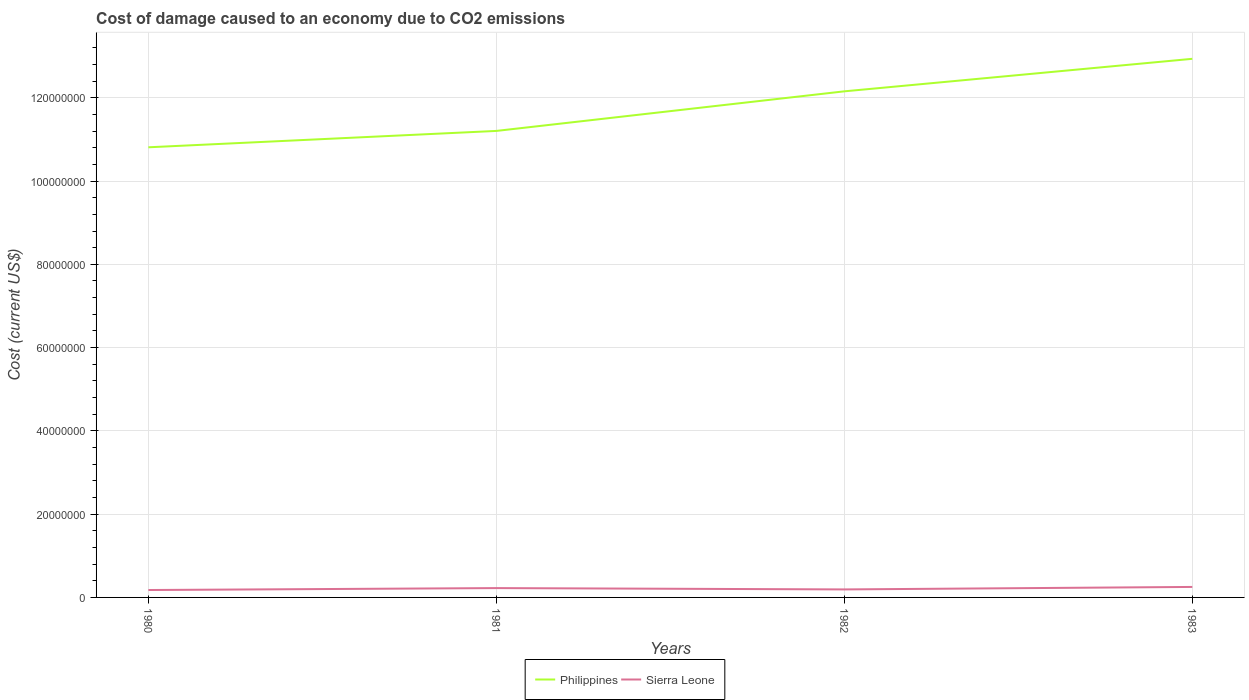Does the line corresponding to Sierra Leone intersect with the line corresponding to Philippines?
Provide a short and direct response. No. Across all years, what is the maximum cost of damage caused due to CO2 emissisons in Sierra Leone?
Give a very brief answer. 1.78e+06. What is the total cost of damage caused due to CO2 emissisons in Sierra Leone in the graph?
Your answer should be compact. -2.78e+05. What is the difference between the highest and the second highest cost of damage caused due to CO2 emissisons in Sierra Leone?
Ensure brevity in your answer.  7.40e+05. What is the difference between the highest and the lowest cost of damage caused due to CO2 emissisons in Philippines?
Your answer should be very brief. 2. Is the cost of damage caused due to CO2 emissisons in Philippines strictly greater than the cost of damage caused due to CO2 emissisons in Sierra Leone over the years?
Make the answer very short. No. How many lines are there?
Provide a succinct answer. 2. How many years are there in the graph?
Your answer should be compact. 4. Where does the legend appear in the graph?
Your response must be concise. Bottom center. What is the title of the graph?
Give a very brief answer. Cost of damage caused to an economy due to CO2 emissions. What is the label or title of the Y-axis?
Your answer should be compact. Cost (current US$). What is the Cost (current US$) of Philippines in 1980?
Your answer should be compact. 1.08e+08. What is the Cost (current US$) of Sierra Leone in 1980?
Give a very brief answer. 1.78e+06. What is the Cost (current US$) of Philippines in 1981?
Your response must be concise. 1.12e+08. What is the Cost (current US$) in Sierra Leone in 1981?
Offer a very short reply. 2.24e+06. What is the Cost (current US$) of Philippines in 1982?
Your answer should be compact. 1.22e+08. What is the Cost (current US$) in Sierra Leone in 1982?
Give a very brief answer. 1.92e+06. What is the Cost (current US$) of Philippines in 1983?
Keep it short and to the point. 1.29e+08. What is the Cost (current US$) in Sierra Leone in 1983?
Provide a succinct answer. 2.52e+06. Across all years, what is the maximum Cost (current US$) of Philippines?
Provide a succinct answer. 1.29e+08. Across all years, what is the maximum Cost (current US$) of Sierra Leone?
Provide a short and direct response. 2.52e+06. Across all years, what is the minimum Cost (current US$) of Philippines?
Keep it short and to the point. 1.08e+08. Across all years, what is the minimum Cost (current US$) of Sierra Leone?
Keep it short and to the point. 1.78e+06. What is the total Cost (current US$) of Philippines in the graph?
Offer a very short reply. 4.71e+08. What is the total Cost (current US$) in Sierra Leone in the graph?
Offer a very short reply. 8.46e+06. What is the difference between the Cost (current US$) in Philippines in 1980 and that in 1981?
Your answer should be compact. -3.93e+06. What is the difference between the Cost (current US$) in Sierra Leone in 1980 and that in 1981?
Make the answer very short. -4.62e+05. What is the difference between the Cost (current US$) of Philippines in 1980 and that in 1982?
Provide a succinct answer. -1.34e+07. What is the difference between the Cost (current US$) in Sierra Leone in 1980 and that in 1982?
Give a very brief answer. -1.44e+05. What is the difference between the Cost (current US$) of Philippines in 1980 and that in 1983?
Keep it short and to the point. -2.13e+07. What is the difference between the Cost (current US$) of Sierra Leone in 1980 and that in 1983?
Provide a succinct answer. -7.40e+05. What is the difference between the Cost (current US$) in Philippines in 1981 and that in 1982?
Offer a terse response. -9.51e+06. What is the difference between the Cost (current US$) of Sierra Leone in 1981 and that in 1982?
Provide a short and direct response. 3.17e+05. What is the difference between the Cost (current US$) of Philippines in 1981 and that in 1983?
Ensure brevity in your answer.  -1.73e+07. What is the difference between the Cost (current US$) of Sierra Leone in 1981 and that in 1983?
Your answer should be compact. -2.78e+05. What is the difference between the Cost (current US$) in Philippines in 1982 and that in 1983?
Make the answer very short. -7.81e+06. What is the difference between the Cost (current US$) of Sierra Leone in 1982 and that in 1983?
Provide a succinct answer. -5.95e+05. What is the difference between the Cost (current US$) in Philippines in 1980 and the Cost (current US$) in Sierra Leone in 1981?
Your response must be concise. 1.06e+08. What is the difference between the Cost (current US$) of Philippines in 1980 and the Cost (current US$) of Sierra Leone in 1982?
Offer a very short reply. 1.06e+08. What is the difference between the Cost (current US$) in Philippines in 1980 and the Cost (current US$) in Sierra Leone in 1983?
Give a very brief answer. 1.06e+08. What is the difference between the Cost (current US$) in Philippines in 1981 and the Cost (current US$) in Sierra Leone in 1982?
Keep it short and to the point. 1.10e+08. What is the difference between the Cost (current US$) in Philippines in 1981 and the Cost (current US$) in Sierra Leone in 1983?
Offer a very short reply. 1.10e+08. What is the difference between the Cost (current US$) of Philippines in 1982 and the Cost (current US$) of Sierra Leone in 1983?
Your answer should be very brief. 1.19e+08. What is the average Cost (current US$) in Philippines per year?
Your response must be concise. 1.18e+08. What is the average Cost (current US$) of Sierra Leone per year?
Your answer should be very brief. 2.12e+06. In the year 1980, what is the difference between the Cost (current US$) in Philippines and Cost (current US$) in Sierra Leone?
Make the answer very short. 1.06e+08. In the year 1981, what is the difference between the Cost (current US$) of Philippines and Cost (current US$) of Sierra Leone?
Your answer should be compact. 1.10e+08. In the year 1982, what is the difference between the Cost (current US$) in Philippines and Cost (current US$) in Sierra Leone?
Keep it short and to the point. 1.20e+08. In the year 1983, what is the difference between the Cost (current US$) of Philippines and Cost (current US$) of Sierra Leone?
Offer a terse response. 1.27e+08. What is the ratio of the Cost (current US$) in Philippines in 1980 to that in 1981?
Ensure brevity in your answer.  0.96. What is the ratio of the Cost (current US$) in Sierra Leone in 1980 to that in 1981?
Provide a short and direct response. 0.79. What is the ratio of the Cost (current US$) of Philippines in 1980 to that in 1982?
Ensure brevity in your answer.  0.89. What is the ratio of the Cost (current US$) in Sierra Leone in 1980 to that in 1982?
Offer a very short reply. 0.92. What is the ratio of the Cost (current US$) of Philippines in 1980 to that in 1983?
Give a very brief answer. 0.84. What is the ratio of the Cost (current US$) in Sierra Leone in 1980 to that in 1983?
Your response must be concise. 0.71. What is the ratio of the Cost (current US$) of Philippines in 1981 to that in 1982?
Offer a terse response. 0.92. What is the ratio of the Cost (current US$) of Sierra Leone in 1981 to that in 1982?
Your response must be concise. 1.16. What is the ratio of the Cost (current US$) of Philippines in 1981 to that in 1983?
Your answer should be compact. 0.87. What is the ratio of the Cost (current US$) of Sierra Leone in 1981 to that in 1983?
Your answer should be compact. 0.89. What is the ratio of the Cost (current US$) in Philippines in 1982 to that in 1983?
Offer a terse response. 0.94. What is the ratio of the Cost (current US$) of Sierra Leone in 1982 to that in 1983?
Offer a very short reply. 0.76. What is the difference between the highest and the second highest Cost (current US$) in Philippines?
Provide a short and direct response. 7.81e+06. What is the difference between the highest and the second highest Cost (current US$) in Sierra Leone?
Your response must be concise. 2.78e+05. What is the difference between the highest and the lowest Cost (current US$) in Philippines?
Offer a terse response. 2.13e+07. What is the difference between the highest and the lowest Cost (current US$) in Sierra Leone?
Keep it short and to the point. 7.40e+05. 